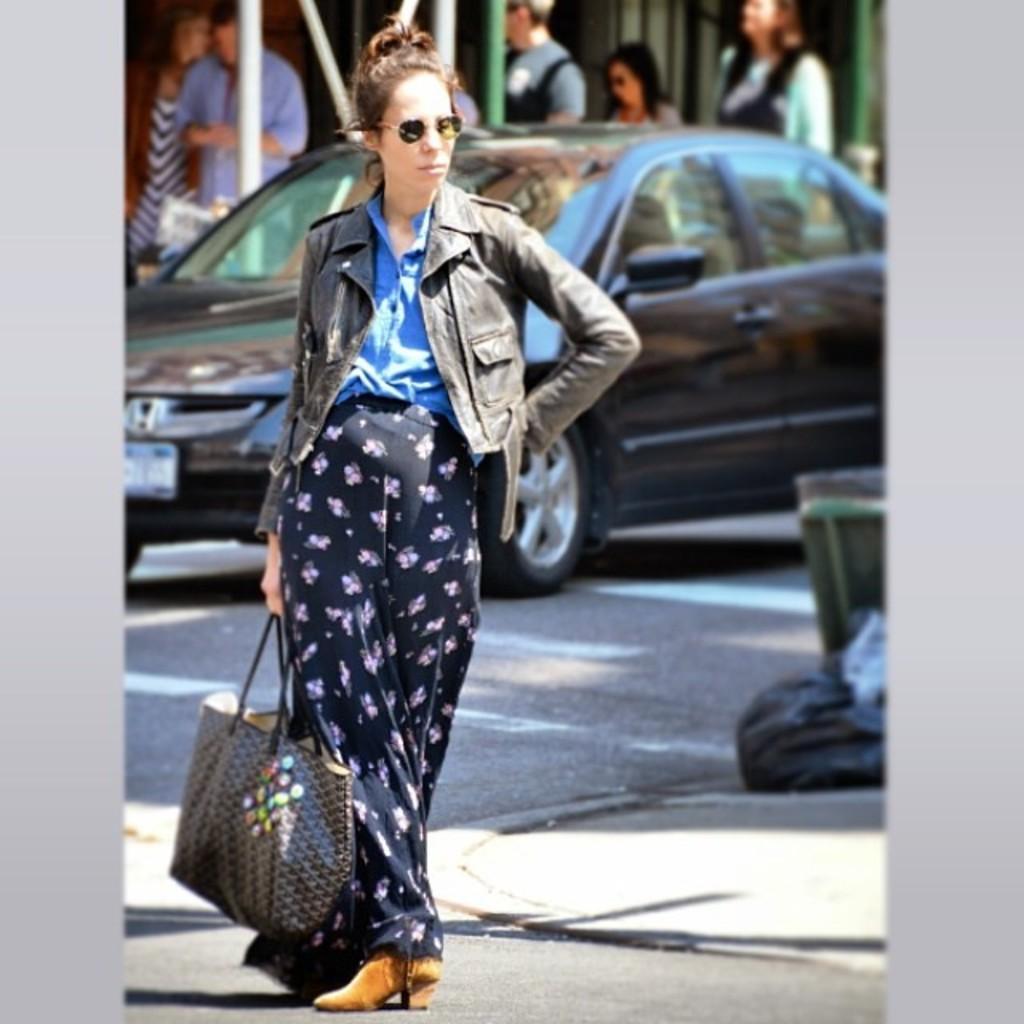In one or two sentences, can you explain what this image depicts? In front of the image there is a lady standing and holding a bag in her hand. And she kept goggles. In the background there is a car. Behind the car there are poles and also there are few people standing. On the right side of the image there are garbage bags. 